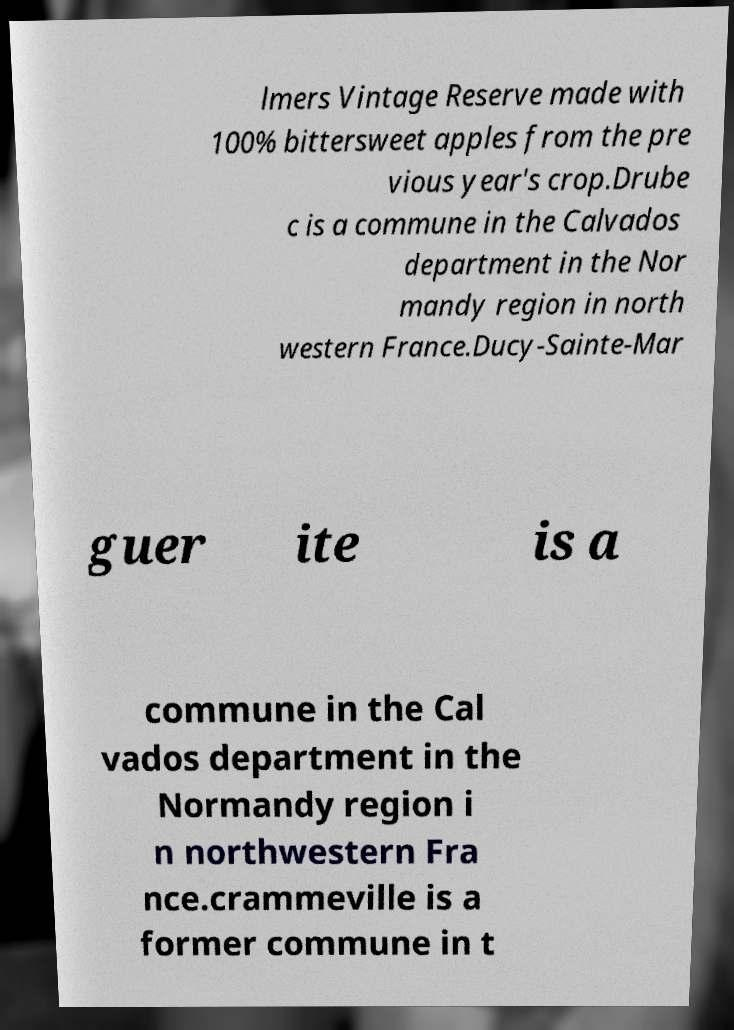Could you assist in decoding the text presented in this image and type it out clearly? lmers Vintage Reserve made with 100% bittersweet apples from the pre vious year's crop.Drube c is a commune in the Calvados department in the Nor mandy region in north western France.Ducy-Sainte-Mar guer ite is a commune in the Cal vados department in the Normandy region i n northwestern Fra nce.crammeville is a former commune in t 